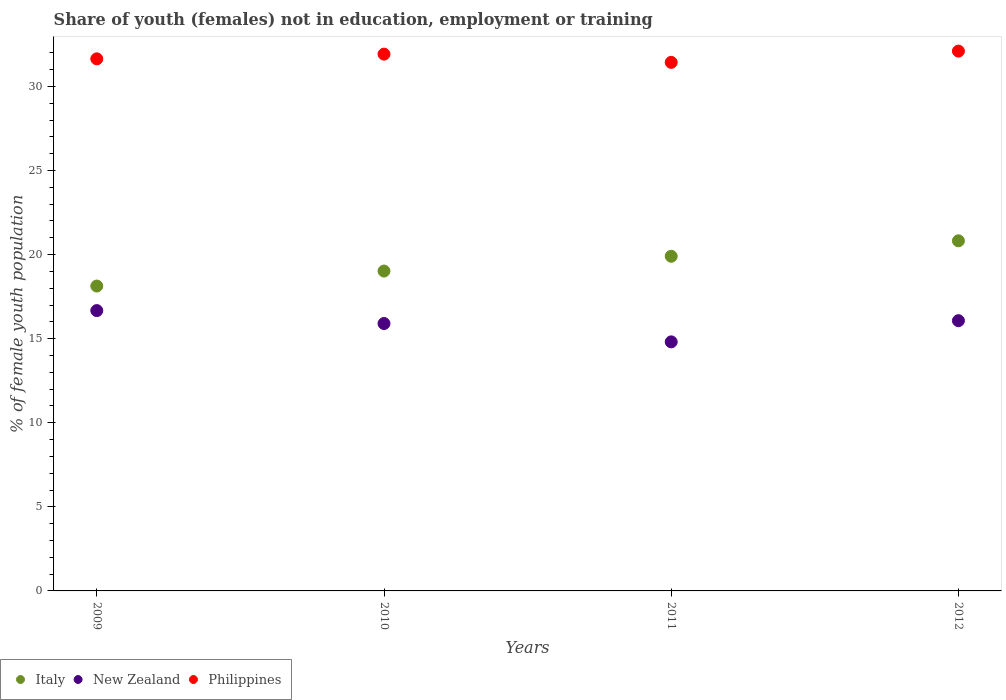How many different coloured dotlines are there?
Offer a terse response. 3. Is the number of dotlines equal to the number of legend labels?
Give a very brief answer. Yes. What is the percentage of unemployed female population in in Philippines in 2010?
Your answer should be very brief. 31.92. Across all years, what is the maximum percentage of unemployed female population in in New Zealand?
Give a very brief answer. 16.67. Across all years, what is the minimum percentage of unemployed female population in in New Zealand?
Provide a succinct answer. 14.81. In which year was the percentage of unemployed female population in in Italy maximum?
Ensure brevity in your answer.  2012. What is the total percentage of unemployed female population in in Italy in the graph?
Make the answer very short. 77.87. What is the difference between the percentage of unemployed female population in in Philippines in 2009 and that in 2011?
Provide a succinct answer. 0.21. What is the difference between the percentage of unemployed female population in in Italy in 2011 and the percentage of unemployed female population in in Philippines in 2012?
Your answer should be compact. -12.2. What is the average percentage of unemployed female population in in New Zealand per year?
Keep it short and to the point. 15.86. In the year 2012, what is the difference between the percentage of unemployed female population in in Philippines and percentage of unemployed female population in in New Zealand?
Your answer should be compact. 16.03. What is the ratio of the percentage of unemployed female population in in Italy in 2011 to that in 2012?
Give a very brief answer. 0.96. Is the difference between the percentage of unemployed female population in in Philippines in 2009 and 2011 greater than the difference between the percentage of unemployed female population in in New Zealand in 2009 and 2011?
Provide a short and direct response. No. What is the difference between the highest and the second highest percentage of unemployed female population in in New Zealand?
Make the answer very short. 0.6. What is the difference between the highest and the lowest percentage of unemployed female population in in Italy?
Give a very brief answer. 2.69. Is it the case that in every year, the sum of the percentage of unemployed female population in in Italy and percentage of unemployed female population in in Philippines  is greater than the percentage of unemployed female population in in New Zealand?
Offer a very short reply. Yes. Does the percentage of unemployed female population in in Philippines monotonically increase over the years?
Provide a succinct answer. No. Is the percentage of unemployed female population in in Philippines strictly greater than the percentage of unemployed female population in in New Zealand over the years?
Offer a very short reply. Yes. Is the percentage of unemployed female population in in Philippines strictly less than the percentage of unemployed female population in in New Zealand over the years?
Ensure brevity in your answer.  No. How many dotlines are there?
Your answer should be very brief. 3. How many years are there in the graph?
Offer a very short reply. 4. Does the graph contain any zero values?
Your answer should be very brief. No. Does the graph contain grids?
Provide a short and direct response. No. Where does the legend appear in the graph?
Make the answer very short. Bottom left. How many legend labels are there?
Give a very brief answer. 3. What is the title of the graph?
Keep it short and to the point. Share of youth (females) not in education, employment or training. What is the label or title of the Y-axis?
Provide a short and direct response. % of female youth population. What is the % of female youth population in Italy in 2009?
Make the answer very short. 18.13. What is the % of female youth population of New Zealand in 2009?
Give a very brief answer. 16.67. What is the % of female youth population in Philippines in 2009?
Your answer should be compact. 31.64. What is the % of female youth population of Italy in 2010?
Offer a terse response. 19.02. What is the % of female youth population of New Zealand in 2010?
Your answer should be very brief. 15.9. What is the % of female youth population of Philippines in 2010?
Your response must be concise. 31.92. What is the % of female youth population in Italy in 2011?
Your answer should be compact. 19.9. What is the % of female youth population in New Zealand in 2011?
Keep it short and to the point. 14.81. What is the % of female youth population in Philippines in 2011?
Offer a terse response. 31.43. What is the % of female youth population in Italy in 2012?
Your answer should be very brief. 20.82. What is the % of female youth population of New Zealand in 2012?
Make the answer very short. 16.07. What is the % of female youth population in Philippines in 2012?
Give a very brief answer. 32.1. Across all years, what is the maximum % of female youth population of Italy?
Your response must be concise. 20.82. Across all years, what is the maximum % of female youth population in New Zealand?
Offer a terse response. 16.67. Across all years, what is the maximum % of female youth population of Philippines?
Offer a terse response. 32.1. Across all years, what is the minimum % of female youth population of Italy?
Provide a short and direct response. 18.13. Across all years, what is the minimum % of female youth population in New Zealand?
Ensure brevity in your answer.  14.81. Across all years, what is the minimum % of female youth population of Philippines?
Make the answer very short. 31.43. What is the total % of female youth population of Italy in the graph?
Your response must be concise. 77.87. What is the total % of female youth population in New Zealand in the graph?
Provide a succinct answer. 63.45. What is the total % of female youth population of Philippines in the graph?
Your answer should be compact. 127.09. What is the difference between the % of female youth population in Italy in 2009 and that in 2010?
Offer a terse response. -0.89. What is the difference between the % of female youth population of New Zealand in 2009 and that in 2010?
Your response must be concise. 0.77. What is the difference between the % of female youth population in Philippines in 2009 and that in 2010?
Provide a succinct answer. -0.28. What is the difference between the % of female youth population in Italy in 2009 and that in 2011?
Keep it short and to the point. -1.77. What is the difference between the % of female youth population in New Zealand in 2009 and that in 2011?
Give a very brief answer. 1.86. What is the difference between the % of female youth population in Philippines in 2009 and that in 2011?
Make the answer very short. 0.21. What is the difference between the % of female youth population in Italy in 2009 and that in 2012?
Your answer should be very brief. -2.69. What is the difference between the % of female youth population in New Zealand in 2009 and that in 2012?
Give a very brief answer. 0.6. What is the difference between the % of female youth population in Philippines in 2009 and that in 2012?
Offer a very short reply. -0.46. What is the difference between the % of female youth population in Italy in 2010 and that in 2011?
Your answer should be compact. -0.88. What is the difference between the % of female youth population in New Zealand in 2010 and that in 2011?
Your response must be concise. 1.09. What is the difference between the % of female youth population in Philippines in 2010 and that in 2011?
Provide a succinct answer. 0.49. What is the difference between the % of female youth population in Italy in 2010 and that in 2012?
Your response must be concise. -1.8. What is the difference between the % of female youth population in New Zealand in 2010 and that in 2012?
Your response must be concise. -0.17. What is the difference between the % of female youth population in Philippines in 2010 and that in 2012?
Provide a short and direct response. -0.18. What is the difference between the % of female youth population in Italy in 2011 and that in 2012?
Provide a short and direct response. -0.92. What is the difference between the % of female youth population of New Zealand in 2011 and that in 2012?
Ensure brevity in your answer.  -1.26. What is the difference between the % of female youth population of Philippines in 2011 and that in 2012?
Your answer should be very brief. -0.67. What is the difference between the % of female youth population of Italy in 2009 and the % of female youth population of New Zealand in 2010?
Provide a succinct answer. 2.23. What is the difference between the % of female youth population in Italy in 2009 and the % of female youth population in Philippines in 2010?
Keep it short and to the point. -13.79. What is the difference between the % of female youth population in New Zealand in 2009 and the % of female youth population in Philippines in 2010?
Give a very brief answer. -15.25. What is the difference between the % of female youth population of Italy in 2009 and the % of female youth population of New Zealand in 2011?
Ensure brevity in your answer.  3.32. What is the difference between the % of female youth population in New Zealand in 2009 and the % of female youth population in Philippines in 2011?
Offer a very short reply. -14.76. What is the difference between the % of female youth population of Italy in 2009 and the % of female youth population of New Zealand in 2012?
Your answer should be compact. 2.06. What is the difference between the % of female youth population of Italy in 2009 and the % of female youth population of Philippines in 2012?
Your answer should be very brief. -13.97. What is the difference between the % of female youth population of New Zealand in 2009 and the % of female youth population of Philippines in 2012?
Make the answer very short. -15.43. What is the difference between the % of female youth population in Italy in 2010 and the % of female youth population in New Zealand in 2011?
Ensure brevity in your answer.  4.21. What is the difference between the % of female youth population of Italy in 2010 and the % of female youth population of Philippines in 2011?
Ensure brevity in your answer.  -12.41. What is the difference between the % of female youth population in New Zealand in 2010 and the % of female youth population in Philippines in 2011?
Offer a terse response. -15.53. What is the difference between the % of female youth population of Italy in 2010 and the % of female youth population of New Zealand in 2012?
Your answer should be very brief. 2.95. What is the difference between the % of female youth population of Italy in 2010 and the % of female youth population of Philippines in 2012?
Your response must be concise. -13.08. What is the difference between the % of female youth population in New Zealand in 2010 and the % of female youth population in Philippines in 2012?
Ensure brevity in your answer.  -16.2. What is the difference between the % of female youth population of Italy in 2011 and the % of female youth population of New Zealand in 2012?
Make the answer very short. 3.83. What is the difference between the % of female youth population of Italy in 2011 and the % of female youth population of Philippines in 2012?
Your response must be concise. -12.2. What is the difference between the % of female youth population in New Zealand in 2011 and the % of female youth population in Philippines in 2012?
Give a very brief answer. -17.29. What is the average % of female youth population in Italy per year?
Offer a terse response. 19.47. What is the average % of female youth population in New Zealand per year?
Provide a short and direct response. 15.86. What is the average % of female youth population of Philippines per year?
Give a very brief answer. 31.77. In the year 2009, what is the difference between the % of female youth population of Italy and % of female youth population of New Zealand?
Give a very brief answer. 1.46. In the year 2009, what is the difference between the % of female youth population in Italy and % of female youth population in Philippines?
Your response must be concise. -13.51. In the year 2009, what is the difference between the % of female youth population of New Zealand and % of female youth population of Philippines?
Keep it short and to the point. -14.97. In the year 2010, what is the difference between the % of female youth population in Italy and % of female youth population in New Zealand?
Your answer should be very brief. 3.12. In the year 2010, what is the difference between the % of female youth population of New Zealand and % of female youth population of Philippines?
Your answer should be compact. -16.02. In the year 2011, what is the difference between the % of female youth population in Italy and % of female youth population in New Zealand?
Provide a succinct answer. 5.09. In the year 2011, what is the difference between the % of female youth population in Italy and % of female youth population in Philippines?
Make the answer very short. -11.53. In the year 2011, what is the difference between the % of female youth population of New Zealand and % of female youth population of Philippines?
Your answer should be very brief. -16.62. In the year 2012, what is the difference between the % of female youth population in Italy and % of female youth population in New Zealand?
Give a very brief answer. 4.75. In the year 2012, what is the difference between the % of female youth population of Italy and % of female youth population of Philippines?
Offer a terse response. -11.28. In the year 2012, what is the difference between the % of female youth population in New Zealand and % of female youth population in Philippines?
Provide a succinct answer. -16.03. What is the ratio of the % of female youth population of Italy in 2009 to that in 2010?
Offer a terse response. 0.95. What is the ratio of the % of female youth population of New Zealand in 2009 to that in 2010?
Your response must be concise. 1.05. What is the ratio of the % of female youth population in Philippines in 2009 to that in 2010?
Offer a very short reply. 0.99. What is the ratio of the % of female youth population of Italy in 2009 to that in 2011?
Offer a very short reply. 0.91. What is the ratio of the % of female youth population in New Zealand in 2009 to that in 2011?
Provide a short and direct response. 1.13. What is the ratio of the % of female youth population in Italy in 2009 to that in 2012?
Your response must be concise. 0.87. What is the ratio of the % of female youth population in New Zealand in 2009 to that in 2012?
Keep it short and to the point. 1.04. What is the ratio of the % of female youth population in Philippines in 2009 to that in 2012?
Keep it short and to the point. 0.99. What is the ratio of the % of female youth population in Italy in 2010 to that in 2011?
Your answer should be compact. 0.96. What is the ratio of the % of female youth population of New Zealand in 2010 to that in 2011?
Ensure brevity in your answer.  1.07. What is the ratio of the % of female youth population of Philippines in 2010 to that in 2011?
Provide a short and direct response. 1.02. What is the ratio of the % of female youth population in Italy in 2010 to that in 2012?
Keep it short and to the point. 0.91. What is the ratio of the % of female youth population of Italy in 2011 to that in 2012?
Give a very brief answer. 0.96. What is the ratio of the % of female youth population of New Zealand in 2011 to that in 2012?
Give a very brief answer. 0.92. What is the ratio of the % of female youth population of Philippines in 2011 to that in 2012?
Offer a terse response. 0.98. What is the difference between the highest and the second highest % of female youth population of New Zealand?
Ensure brevity in your answer.  0.6. What is the difference between the highest and the second highest % of female youth population in Philippines?
Provide a short and direct response. 0.18. What is the difference between the highest and the lowest % of female youth population of Italy?
Provide a succinct answer. 2.69. What is the difference between the highest and the lowest % of female youth population in New Zealand?
Your answer should be compact. 1.86. What is the difference between the highest and the lowest % of female youth population of Philippines?
Your response must be concise. 0.67. 